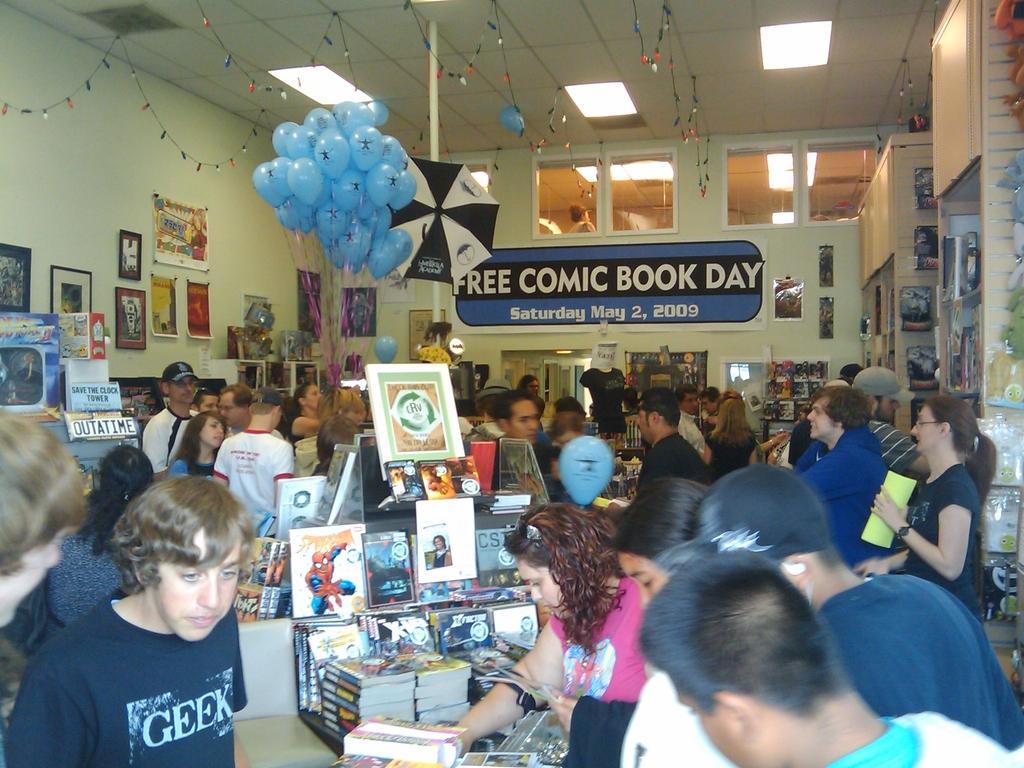In one or two sentences, can you explain what this image depicts? In this image I can see there are group of persons standing and I can see books and balloons and lights and notice papers and the wall visible. 